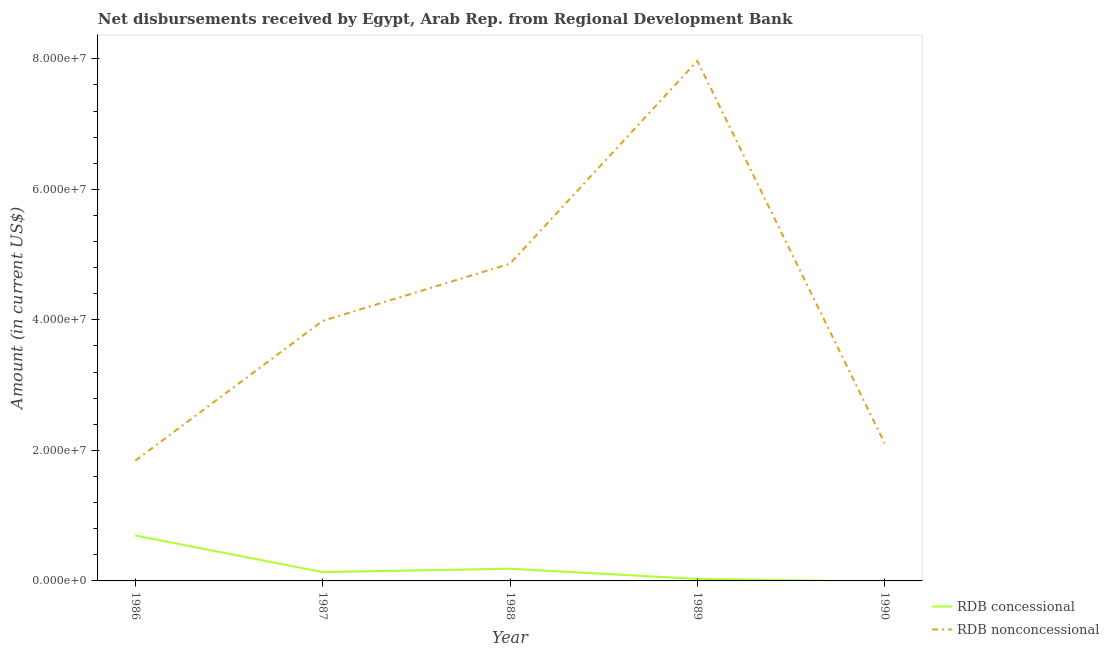Does the line corresponding to net concessional disbursements from rdb intersect with the line corresponding to net non concessional disbursements from rdb?
Give a very brief answer. No. Is the number of lines equal to the number of legend labels?
Offer a very short reply. No. What is the net non concessional disbursements from rdb in 1988?
Provide a succinct answer. 4.86e+07. Across all years, what is the maximum net non concessional disbursements from rdb?
Make the answer very short. 7.97e+07. Across all years, what is the minimum net concessional disbursements from rdb?
Keep it short and to the point. 0. In which year was the net non concessional disbursements from rdb maximum?
Your answer should be compact. 1989. What is the total net non concessional disbursements from rdb in the graph?
Offer a terse response. 2.08e+08. What is the difference between the net concessional disbursements from rdb in 1986 and that in 1989?
Provide a short and direct response. 6.65e+06. What is the difference between the net non concessional disbursements from rdb in 1989 and the net concessional disbursements from rdb in 1986?
Provide a short and direct response. 7.27e+07. What is the average net non concessional disbursements from rdb per year?
Your answer should be very brief. 4.15e+07. In the year 1987, what is the difference between the net non concessional disbursements from rdb and net concessional disbursements from rdb?
Your answer should be compact. 3.85e+07. In how many years, is the net concessional disbursements from rdb greater than 28000000 US$?
Offer a very short reply. 0. What is the ratio of the net non concessional disbursements from rdb in 1986 to that in 1987?
Provide a short and direct response. 0.46. Is the net concessional disbursements from rdb in 1987 less than that in 1989?
Your answer should be compact. No. Is the difference between the net concessional disbursements from rdb in 1987 and 1988 greater than the difference between the net non concessional disbursements from rdb in 1987 and 1988?
Make the answer very short. Yes. What is the difference between the highest and the second highest net concessional disbursements from rdb?
Your answer should be compact. 5.09e+06. What is the difference between the highest and the lowest net non concessional disbursements from rdb?
Your answer should be very brief. 6.13e+07. In how many years, is the net non concessional disbursements from rdb greater than the average net non concessional disbursements from rdb taken over all years?
Offer a terse response. 2. Is the sum of the net concessional disbursements from rdb in 1986 and 1987 greater than the maximum net non concessional disbursements from rdb across all years?
Your response must be concise. No. Is the net concessional disbursements from rdb strictly greater than the net non concessional disbursements from rdb over the years?
Your answer should be very brief. No. Is the net non concessional disbursements from rdb strictly less than the net concessional disbursements from rdb over the years?
Offer a very short reply. No. How many lines are there?
Ensure brevity in your answer.  2. Does the graph contain any zero values?
Keep it short and to the point. Yes. What is the title of the graph?
Give a very brief answer. Net disbursements received by Egypt, Arab Rep. from Regional Development Bank. Does "Working capital" appear as one of the legend labels in the graph?
Make the answer very short. No. What is the Amount (in current US$) in RDB concessional in 1986?
Offer a very short reply. 6.96e+06. What is the Amount (in current US$) in RDB nonconcessional in 1986?
Provide a succinct answer. 1.84e+07. What is the Amount (in current US$) in RDB concessional in 1987?
Offer a very short reply. 1.36e+06. What is the Amount (in current US$) of RDB nonconcessional in 1987?
Your answer should be compact. 3.99e+07. What is the Amount (in current US$) of RDB concessional in 1988?
Give a very brief answer. 1.87e+06. What is the Amount (in current US$) in RDB nonconcessional in 1988?
Ensure brevity in your answer.  4.86e+07. What is the Amount (in current US$) in RDB concessional in 1989?
Your response must be concise. 3.08e+05. What is the Amount (in current US$) in RDB nonconcessional in 1989?
Provide a succinct answer. 7.97e+07. What is the Amount (in current US$) in RDB concessional in 1990?
Offer a terse response. 0. What is the Amount (in current US$) in RDB nonconcessional in 1990?
Ensure brevity in your answer.  2.11e+07. Across all years, what is the maximum Amount (in current US$) in RDB concessional?
Your answer should be compact. 6.96e+06. Across all years, what is the maximum Amount (in current US$) of RDB nonconcessional?
Ensure brevity in your answer.  7.97e+07. Across all years, what is the minimum Amount (in current US$) in RDB concessional?
Give a very brief answer. 0. Across all years, what is the minimum Amount (in current US$) of RDB nonconcessional?
Give a very brief answer. 1.84e+07. What is the total Amount (in current US$) of RDB concessional in the graph?
Provide a succinct answer. 1.05e+07. What is the total Amount (in current US$) of RDB nonconcessional in the graph?
Offer a very short reply. 2.08e+08. What is the difference between the Amount (in current US$) in RDB concessional in 1986 and that in 1987?
Your answer should be very brief. 5.60e+06. What is the difference between the Amount (in current US$) in RDB nonconcessional in 1986 and that in 1987?
Your response must be concise. -2.14e+07. What is the difference between the Amount (in current US$) of RDB concessional in 1986 and that in 1988?
Offer a very short reply. 5.09e+06. What is the difference between the Amount (in current US$) of RDB nonconcessional in 1986 and that in 1988?
Offer a very short reply. -3.02e+07. What is the difference between the Amount (in current US$) in RDB concessional in 1986 and that in 1989?
Your answer should be compact. 6.65e+06. What is the difference between the Amount (in current US$) in RDB nonconcessional in 1986 and that in 1989?
Your answer should be very brief. -6.13e+07. What is the difference between the Amount (in current US$) in RDB nonconcessional in 1986 and that in 1990?
Offer a terse response. -2.66e+06. What is the difference between the Amount (in current US$) in RDB concessional in 1987 and that in 1988?
Your answer should be very brief. -5.12e+05. What is the difference between the Amount (in current US$) in RDB nonconcessional in 1987 and that in 1988?
Your answer should be compact. -8.76e+06. What is the difference between the Amount (in current US$) of RDB concessional in 1987 and that in 1989?
Make the answer very short. 1.05e+06. What is the difference between the Amount (in current US$) of RDB nonconcessional in 1987 and that in 1989?
Offer a very short reply. -3.98e+07. What is the difference between the Amount (in current US$) in RDB nonconcessional in 1987 and that in 1990?
Your response must be concise. 1.88e+07. What is the difference between the Amount (in current US$) in RDB concessional in 1988 and that in 1989?
Provide a succinct answer. 1.56e+06. What is the difference between the Amount (in current US$) of RDB nonconcessional in 1988 and that in 1989?
Your response must be concise. -3.11e+07. What is the difference between the Amount (in current US$) of RDB nonconcessional in 1988 and that in 1990?
Your answer should be compact. 2.75e+07. What is the difference between the Amount (in current US$) of RDB nonconcessional in 1989 and that in 1990?
Offer a terse response. 5.86e+07. What is the difference between the Amount (in current US$) in RDB concessional in 1986 and the Amount (in current US$) in RDB nonconcessional in 1987?
Offer a terse response. -3.29e+07. What is the difference between the Amount (in current US$) of RDB concessional in 1986 and the Amount (in current US$) of RDB nonconcessional in 1988?
Keep it short and to the point. -4.17e+07. What is the difference between the Amount (in current US$) of RDB concessional in 1986 and the Amount (in current US$) of RDB nonconcessional in 1989?
Make the answer very short. -7.27e+07. What is the difference between the Amount (in current US$) in RDB concessional in 1986 and the Amount (in current US$) in RDB nonconcessional in 1990?
Ensure brevity in your answer.  -1.41e+07. What is the difference between the Amount (in current US$) in RDB concessional in 1987 and the Amount (in current US$) in RDB nonconcessional in 1988?
Your answer should be very brief. -4.73e+07. What is the difference between the Amount (in current US$) in RDB concessional in 1987 and the Amount (in current US$) in RDB nonconcessional in 1989?
Your response must be concise. -7.83e+07. What is the difference between the Amount (in current US$) of RDB concessional in 1987 and the Amount (in current US$) of RDB nonconcessional in 1990?
Ensure brevity in your answer.  -1.97e+07. What is the difference between the Amount (in current US$) of RDB concessional in 1988 and the Amount (in current US$) of RDB nonconcessional in 1989?
Give a very brief answer. -7.78e+07. What is the difference between the Amount (in current US$) in RDB concessional in 1988 and the Amount (in current US$) in RDB nonconcessional in 1990?
Your answer should be very brief. -1.92e+07. What is the difference between the Amount (in current US$) in RDB concessional in 1989 and the Amount (in current US$) in RDB nonconcessional in 1990?
Provide a succinct answer. -2.08e+07. What is the average Amount (in current US$) in RDB concessional per year?
Keep it short and to the point. 2.10e+06. What is the average Amount (in current US$) in RDB nonconcessional per year?
Your answer should be compact. 4.15e+07. In the year 1986, what is the difference between the Amount (in current US$) in RDB concessional and Amount (in current US$) in RDB nonconcessional?
Offer a terse response. -1.15e+07. In the year 1987, what is the difference between the Amount (in current US$) of RDB concessional and Amount (in current US$) of RDB nonconcessional?
Your answer should be very brief. -3.85e+07. In the year 1988, what is the difference between the Amount (in current US$) of RDB concessional and Amount (in current US$) of RDB nonconcessional?
Give a very brief answer. -4.67e+07. In the year 1989, what is the difference between the Amount (in current US$) of RDB concessional and Amount (in current US$) of RDB nonconcessional?
Make the answer very short. -7.94e+07. What is the ratio of the Amount (in current US$) in RDB concessional in 1986 to that in 1987?
Give a very brief answer. 5.13. What is the ratio of the Amount (in current US$) in RDB nonconcessional in 1986 to that in 1987?
Offer a very short reply. 0.46. What is the ratio of the Amount (in current US$) in RDB concessional in 1986 to that in 1988?
Provide a succinct answer. 3.72. What is the ratio of the Amount (in current US$) in RDB nonconcessional in 1986 to that in 1988?
Make the answer very short. 0.38. What is the ratio of the Amount (in current US$) in RDB concessional in 1986 to that in 1989?
Keep it short and to the point. 22.58. What is the ratio of the Amount (in current US$) of RDB nonconcessional in 1986 to that in 1989?
Give a very brief answer. 0.23. What is the ratio of the Amount (in current US$) in RDB nonconcessional in 1986 to that in 1990?
Your answer should be very brief. 0.87. What is the ratio of the Amount (in current US$) in RDB concessional in 1987 to that in 1988?
Provide a succinct answer. 0.73. What is the ratio of the Amount (in current US$) of RDB nonconcessional in 1987 to that in 1988?
Provide a succinct answer. 0.82. What is the ratio of the Amount (in current US$) in RDB concessional in 1987 to that in 1989?
Ensure brevity in your answer.  4.4. What is the ratio of the Amount (in current US$) of RDB nonconcessional in 1987 to that in 1989?
Offer a very short reply. 0.5. What is the ratio of the Amount (in current US$) in RDB nonconcessional in 1987 to that in 1990?
Make the answer very short. 1.89. What is the ratio of the Amount (in current US$) in RDB concessional in 1988 to that in 1989?
Provide a short and direct response. 6.06. What is the ratio of the Amount (in current US$) in RDB nonconcessional in 1988 to that in 1989?
Make the answer very short. 0.61. What is the ratio of the Amount (in current US$) in RDB nonconcessional in 1988 to that in 1990?
Provide a short and direct response. 2.3. What is the ratio of the Amount (in current US$) in RDB nonconcessional in 1989 to that in 1990?
Keep it short and to the point. 3.78. What is the difference between the highest and the second highest Amount (in current US$) of RDB concessional?
Keep it short and to the point. 5.09e+06. What is the difference between the highest and the second highest Amount (in current US$) of RDB nonconcessional?
Offer a terse response. 3.11e+07. What is the difference between the highest and the lowest Amount (in current US$) in RDB concessional?
Offer a terse response. 6.96e+06. What is the difference between the highest and the lowest Amount (in current US$) in RDB nonconcessional?
Provide a short and direct response. 6.13e+07. 